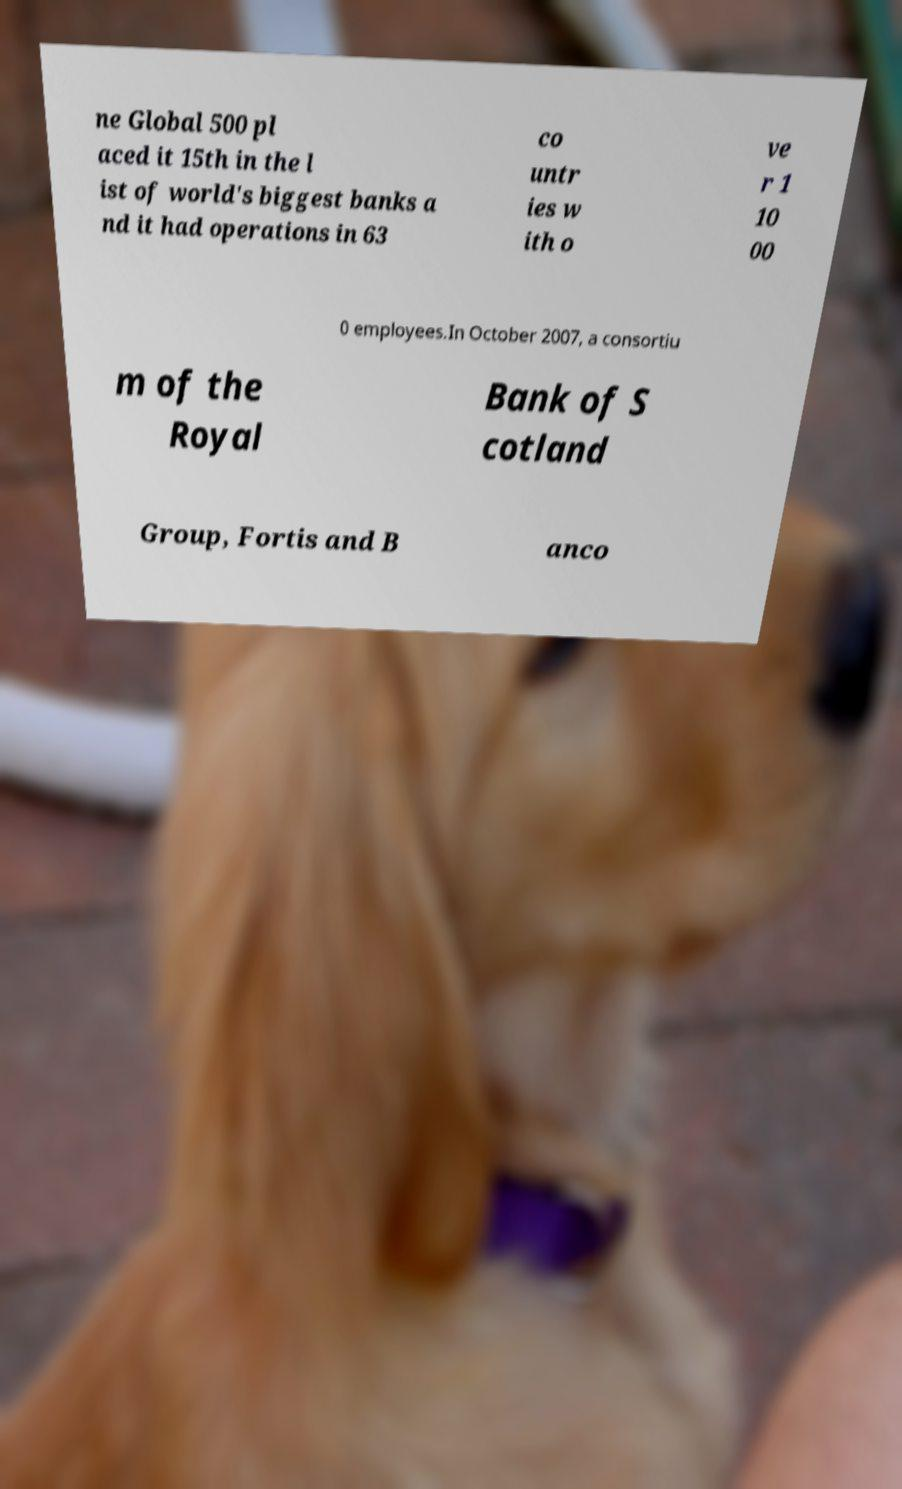Could you assist in decoding the text presented in this image and type it out clearly? ne Global 500 pl aced it 15th in the l ist of world's biggest banks a nd it had operations in 63 co untr ies w ith o ve r 1 10 00 0 employees.In October 2007, a consortiu m of the Royal Bank of S cotland Group, Fortis and B anco 